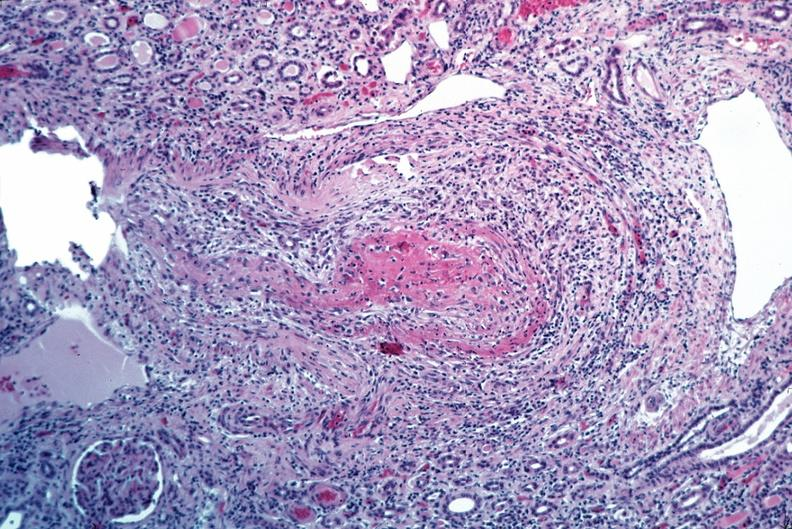what does this image show?
Answer the question using a single word or phrase. Vasculitis 